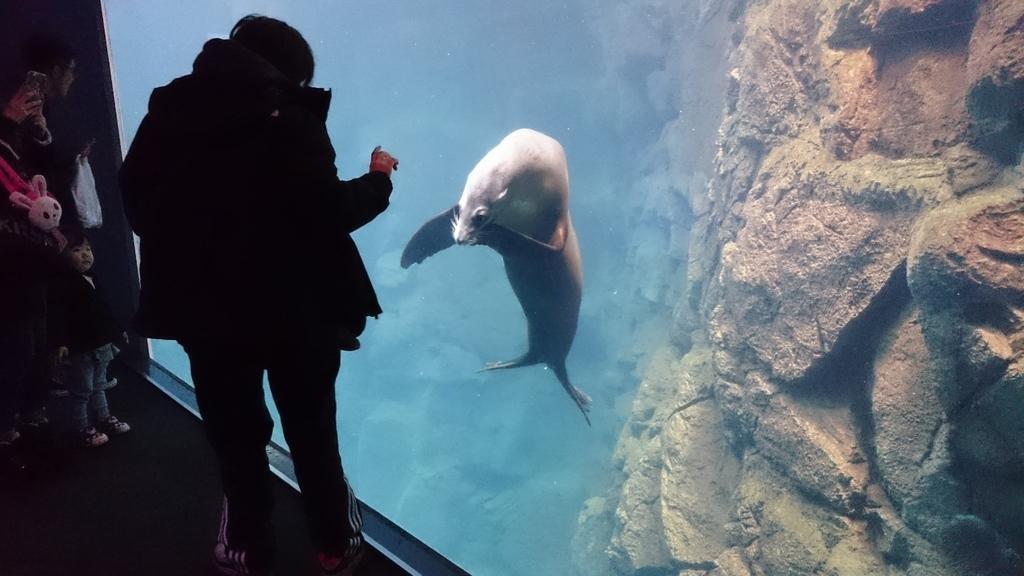How would you summarize this image in a sentence or two? In this image we can see a few people, among them some people are holding the objects, also we can see a shark in the water, on the right side of the image we can see the wall. 